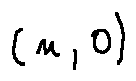<formula> <loc_0><loc_0><loc_500><loc_500>( n , 0 )</formula> 